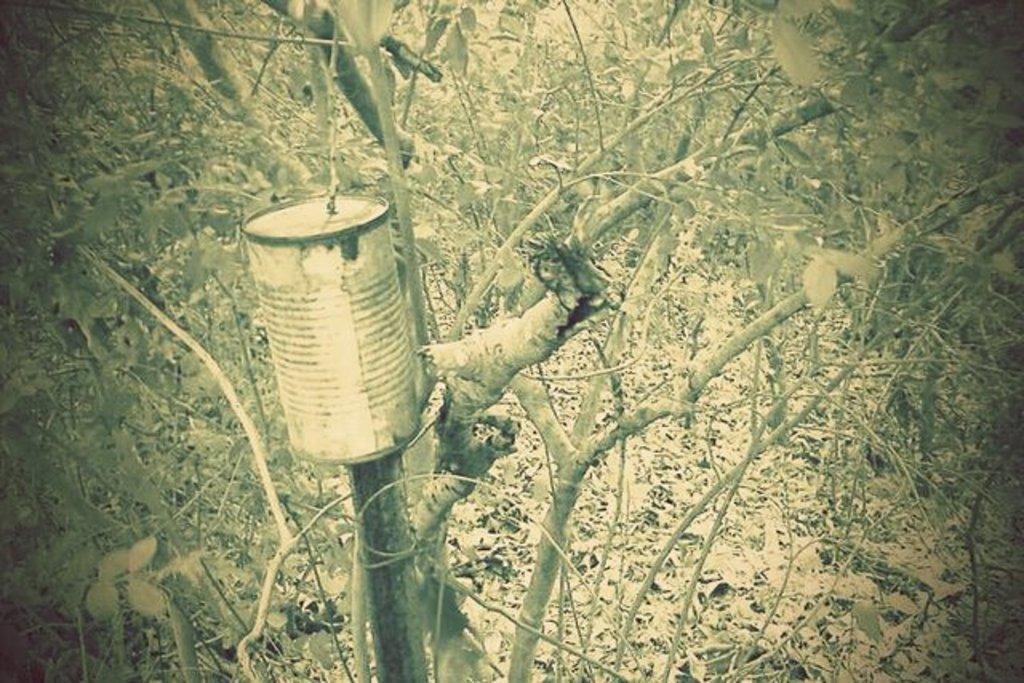How would you summarize this image in a sentence or two? In this picture we can see a box, trees and leaves on the ground. 